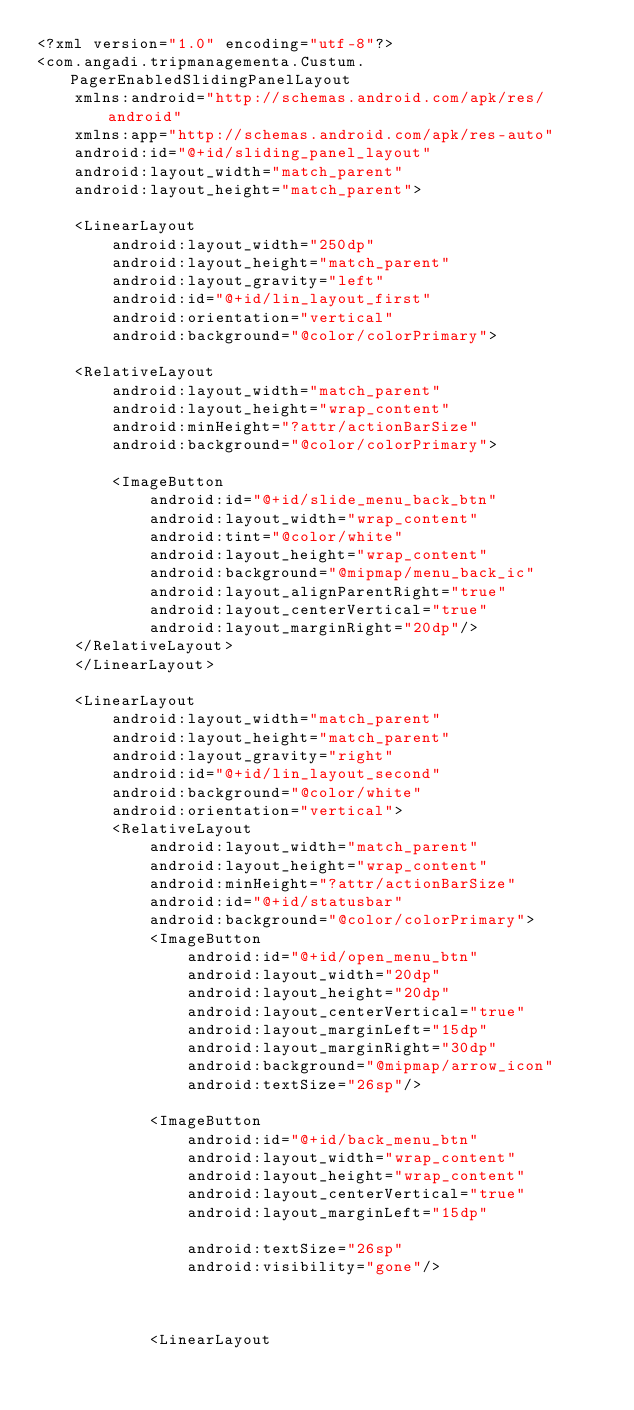Convert code to text. <code><loc_0><loc_0><loc_500><loc_500><_XML_><?xml version="1.0" encoding="utf-8"?>
<com.angadi.tripmanagementa.Custum.PagerEnabledSlidingPanelLayout
    xmlns:android="http://schemas.android.com/apk/res/android"
    xmlns:app="http://schemas.android.com/apk/res-auto"
    android:id="@+id/sliding_panel_layout"
    android:layout_width="match_parent"
    android:layout_height="match_parent">

    <LinearLayout
        android:layout_width="250dp"
        android:layout_height="match_parent"
        android:layout_gravity="left"
        android:id="@+id/lin_layout_first"
        android:orientation="vertical"
        android:background="@color/colorPrimary">

    <RelativeLayout
        android:layout_width="match_parent"
        android:layout_height="wrap_content"
        android:minHeight="?attr/actionBarSize"
        android:background="@color/colorPrimary">

        <ImageButton
            android:id="@+id/slide_menu_back_btn"
            android:layout_width="wrap_content"
            android:tint="@color/white"
            android:layout_height="wrap_content"
            android:background="@mipmap/menu_back_ic"
            android:layout_alignParentRight="true"
            android:layout_centerVertical="true"
            android:layout_marginRight="20dp"/>
    </RelativeLayout>
    </LinearLayout>

    <LinearLayout
        android:layout_width="match_parent"
        android:layout_height="match_parent"
        android:layout_gravity="right"
        android:id="@+id/lin_layout_second"
        android:background="@color/white"
        android:orientation="vertical">
        <RelativeLayout
            android:layout_width="match_parent"
            android:layout_height="wrap_content"
            android:minHeight="?attr/actionBarSize"
            android:id="@+id/statusbar"
            android:background="@color/colorPrimary">
            <ImageButton
                android:id="@+id/open_menu_btn"
                android:layout_width="20dp"
                android:layout_height="20dp"
                android:layout_centerVertical="true"
                android:layout_marginLeft="15dp"
                android:layout_marginRight="30dp"
                android:background="@mipmap/arrow_icon"
                android:textSize="26sp"/>

            <ImageButton
                android:id="@+id/back_menu_btn"
                android:layout_width="wrap_content"
                android:layout_height="wrap_content"
                android:layout_centerVertical="true"
                android:layout_marginLeft="15dp"

                android:textSize="26sp"
                android:visibility="gone"/>



            <LinearLayout</code> 